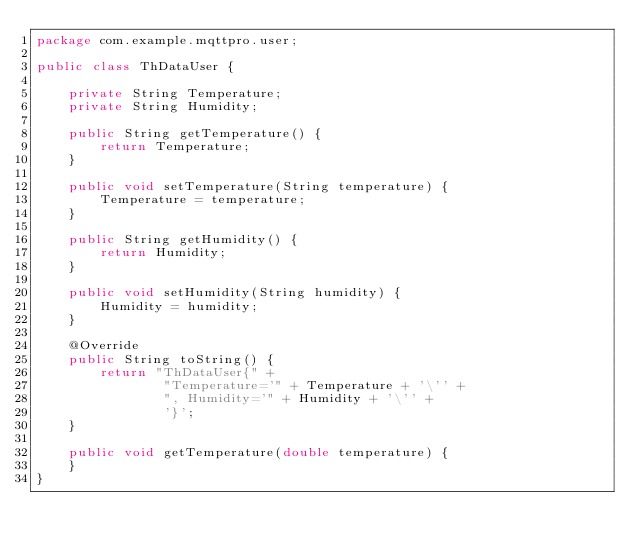Convert code to text. <code><loc_0><loc_0><loc_500><loc_500><_Java_>package com.example.mqttpro.user;

public class ThDataUser {

    private String Temperature;
    private String Humidity;

    public String getTemperature() {
        return Temperature;
    }

    public void setTemperature(String temperature) {
        Temperature = temperature;
    }

    public String getHumidity() {
        return Humidity;
    }

    public void setHumidity(String humidity) {
        Humidity = humidity;
    }

    @Override
    public String toString() {
        return "ThDataUser{" +
                "Temperature='" + Temperature + '\'' +
                ", Humidity='" + Humidity + '\'' +
                '}';
    }

    public void getTemperature(double temperature) {
    }
}
</code> 